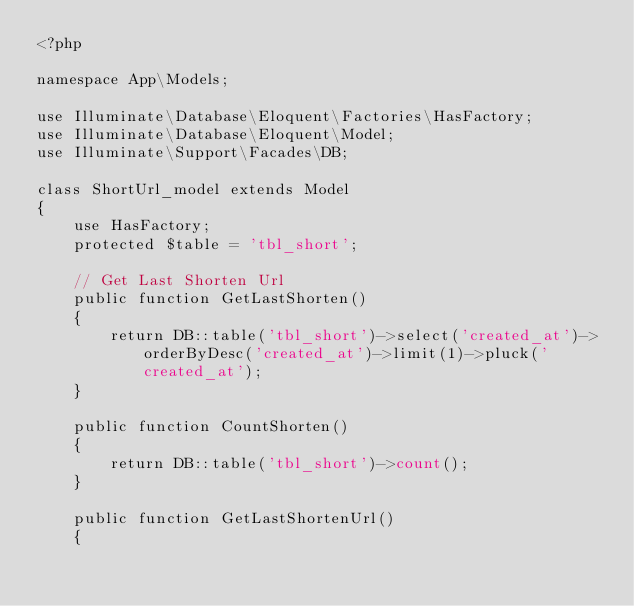<code> <loc_0><loc_0><loc_500><loc_500><_PHP_><?php

namespace App\Models;

use Illuminate\Database\Eloquent\Factories\HasFactory;
use Illuminate\Database\Eloquent\Model;
use Illuminate\Support\Facades\DB;

class ShortUrl_model extends Model
{
    use HasFactory;
    protected $table = 'tbl_short';

    // Get Last Shorten Url
    public function GetLastShorten()
    {
        return DB::table('tbl_short')->select('created_at')->orderByDesc('created_at')->limit(1)->pluck('created_at');
    }

    public function CountShorten()
    {
        return DB::table('tbl_short')->count();
    }

    public function GetLastShortenUrl()
    {</code> 